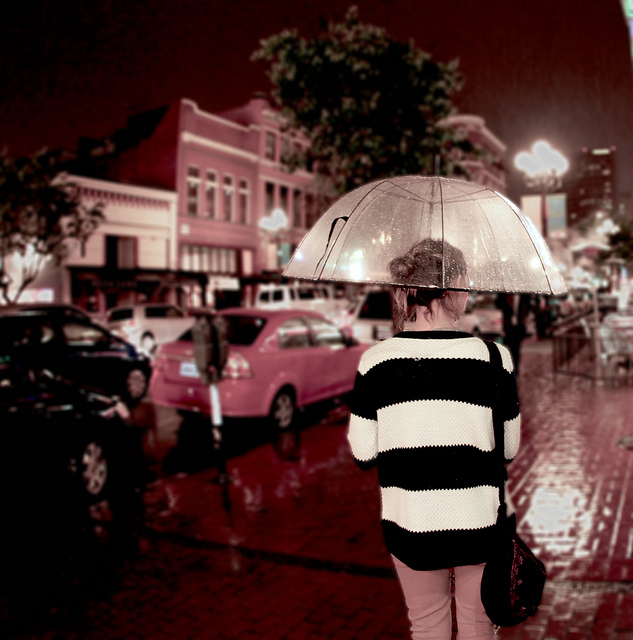<image>Is this photo filtered? I can't be sure if the photo is filtered. Is this photo filtered? I don't know if this photo is filtered. It can be both filtered or not. 